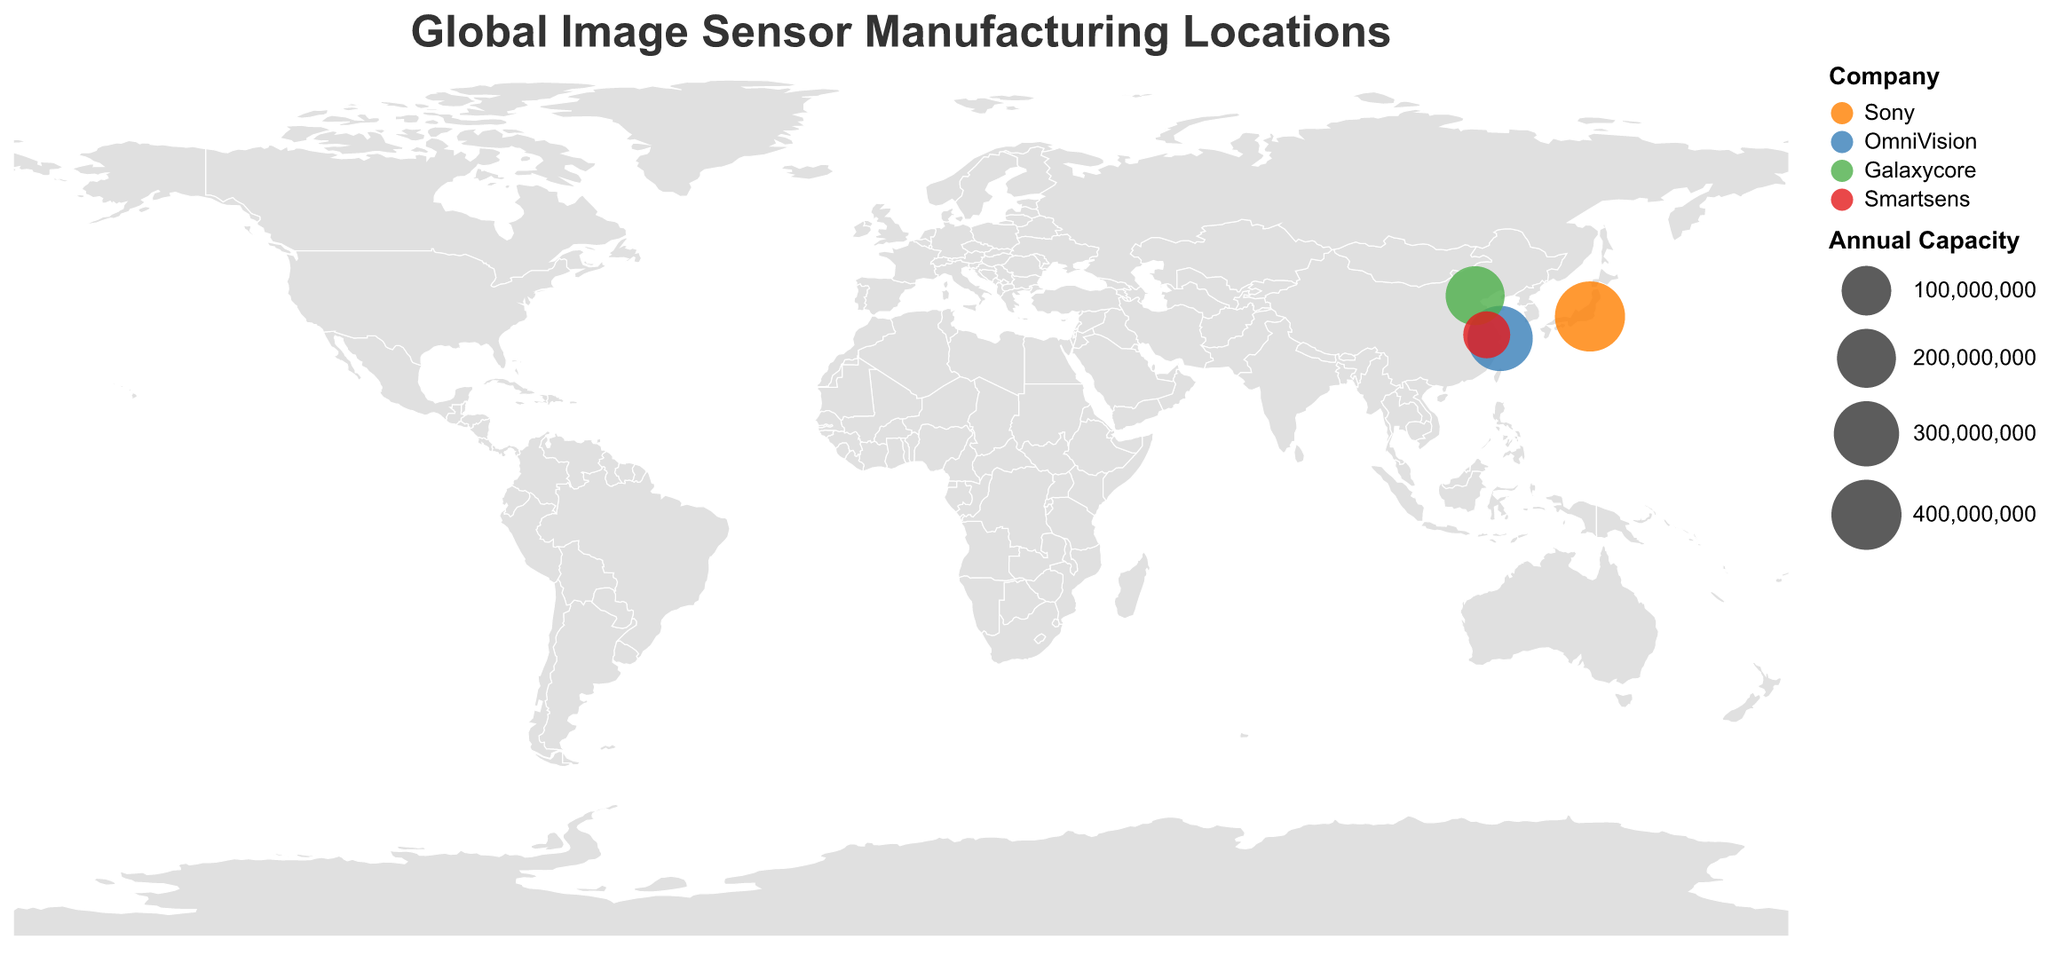How many companies are represented on this map? The map displays four distinct circles, each representing a different company in the image sensor manufacturing sector. The tooltip or color legend can confirm the company names.
Answer: 4 Which company has the highest annual production capacity in this map? The size of the circles is proportional to the annual production capacity, with Sony's circle being the largest.
Answer: Sony Which cities are shown on the map with image sensor manufacturing locations? By hovering over each circle, the tooltips reveal the cities: Tokyo, Shanghai, Beijing, and Nanjing.
Answer: Tokyo, Shanghai, Beijing, Nanjing What is the total combined annual production capacity of all companies? Sum the annual capacities: 400,000,000 (Sony) + 300,000,000 (OmniVision) + 200,000,000 (Galaxycore) + 80,000,000 (Smartsens).
Answer: 980,000,000 Which company uses the same sensor types? By referring to the tooltips, all companies (Sony, OmniVision, Galaxycore, Smartsens) are shown to manufacture CMOS sensors.
Answer: All companies How do Tokyo and Shanghai compare in terms of annual production capacity? Tokyo (Sony) has an annual capacity of 400,000,000, whereas Shanghai (OmniVision) has 300,000,000.
Answer: Tokyo > Shanghai What is the average annual production capacity per company? Calculate the average by dividing the total capacity by the number of companies: 980,000,000 / 4.
Answer: 245,000,000 Among the companies listed, which one has the lowest annual production capacity? The smallest circle size indicates that Smartsens in Nanjing has the lowest capacity of 80,000,000.
Answer: Smartsens What is the sensor type used by Galaxycore? By referring to the tooltip for the Beijing location, Galaxycore manufactures CMOS sensors.
Answer: CMOS 